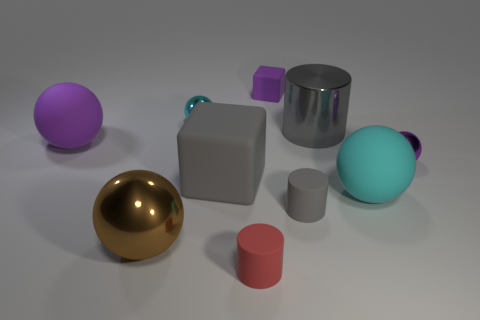There is a shiny cylinder; how many small purple objects are right of it? To the right of the shiny cylinder, there is one small purple object, which appears to be a cube. 